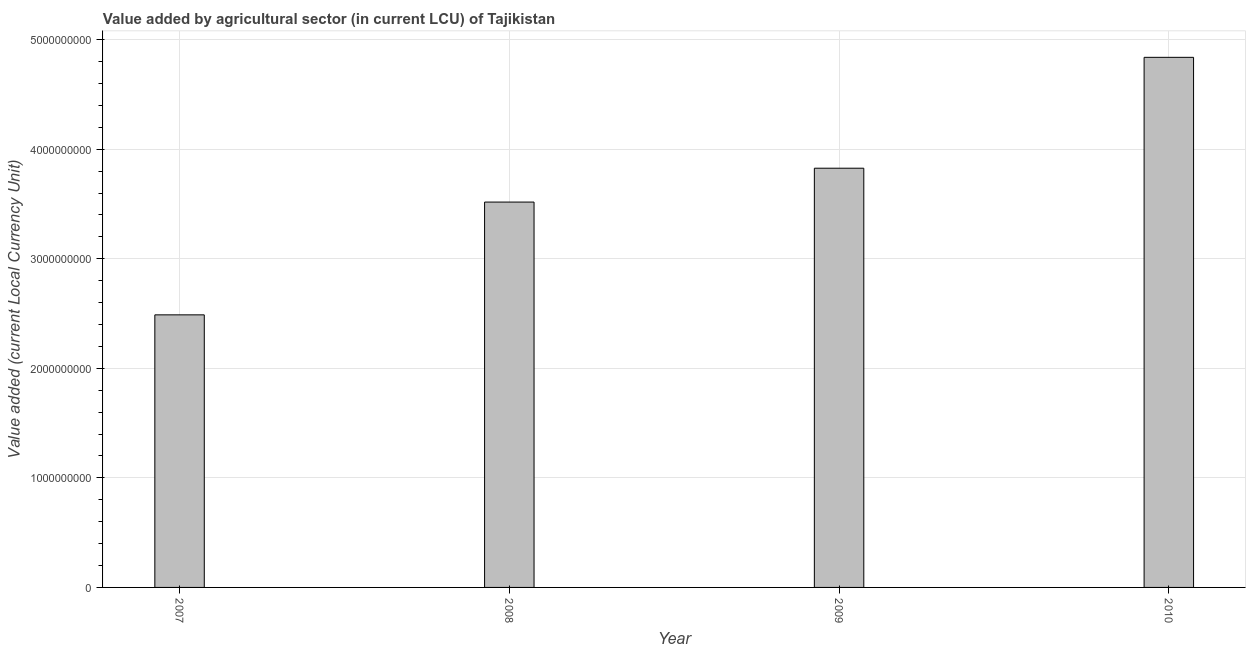Does the graph contain any zero values?
Offer a terse response. No. Does the graph contain grids?
Your answer should be compact. Yes. What is the title of the graph?
Provide a succinct answer. Value added by agricultural sector (in current LCU) of Tajikistan. What is the label or title of the Y-axis?
Offer a terse response. Value added (current Local Currency Unit). What is the value added by agriculture sector in 2009?
Keep it short and to the point. 3.83e+09. Across all years, what is the maximum value added by agriculture sector?
Your answer should be very brief. 4.84e+09. Across all years, what is the minimum value added by agriculture sector?
Make the answer very short. 2.49e+09. In which year was the value added by agriculture sector minimum?
Make the answer very short. 2007. What is the sum of the value added by agriculture sector?
Ensure brevity in your answer.  1.47e+1. What is the difference between the value added by agriculture sector in 2007 and 2010?
Provide a succinct answer. -2.35e+09. What is the average value added by agriculture sector per year?
Provide a short and direct response. 3.67e+09. What is the median value added by agriculture sector?
Provide a succinct answer. 3.67e+09. Do a majority of the years between 2008 and 2009 (inclusive) have value added by agriculture sector greater than 4000000000 LCU?
Provide a short and direct response. No. What is the ratio of the value added by agriculture sector in 2008 to that in 2009?
Provide a short and direct response. 0.92. What is the difference between the highest and the second highest value added by agriculture sector?
Your answer should be very brief. 1.01e+09. Is the sum of the value added by agriculture sector in 2007 and 2009 greater than the maximum value added by agriculture sector across all years?
Offer a terse response. Yes. What is the difference between the highest and the lowest value added by agriculture sector?
Offer a very short reply. 2.35e+09. In how many years, is the value added by agriculture sector greater than the average value added by agriculture sector taken over all years?
Offer a terse response. 2. How many bars are there?
Your answer should be compact. 4. Are all the bars in the graph horizontal?
Provide a short and direct response. No. How many years are there in the graph?
Provide a short and direct response. 4. Are the values on the major ticks of Y-axis written in scientific E-notation?
Provide a short and direct response. No. What is the Value added (current Local Currency Unit) in 2007?
Make the answer very short. 2.49e+09. What is the Value added (current Local Currency Unit) in 2008?
Make the answer very short. 3.52e+09. What is the Value added (current Local Currency Unit) in 2009?
Offer a very short reply. 3.83e+09. What is the Value added (current Local Currency Unit) in 2010?
Ensure brevity in your answer.  4.84e+09. What is the difference between the Value added (current Local Currency Unit) in 2007 and 2008?
Keep it short and to the point. -1.03e+09. What is the difference between the Value added (current Local Currency Unit) in 2007 and 2009?
Keep it short and to the point. -1.34e+09. What is the difference between the Value added (current Local Currency Unit) in 2007 and 2010?
Keep it short and to the point. -2.35e+09. What is the difference between the Value added (current Local Currency Unit) in 2008 and 2009?
Make the answer very short. -3.09e+08. What is the difference between the Value added (current Local Currency Unit) in 2008 and 2010?
Your response must be concise. -1.32e+09. What is the difference between the Value added (current Local Currency Unit) in 2009 and 2010?
Offer a terse response. -1.01e+09. What is the ratio of the Value added (current Local Currency Unit) in 2007 to that in 2008?
Give a very brief answer. 0.71. What is the ratio of the Value added (current Local Currency Unit) in 2007 to that in 2009?
Make the answer very short. 0.65. What is the ratio of the Value added (current Local Currency Unit) in 2007 to that in 2010?
Make the answer very short. 0.51. What is the ratio of the Value added (current Local Currency Unit) in 2008 to that in 2009?
Ensure brevity in your answer.  0.92. What is the ratio of the Value added (current Local Currency Unit) in 2008 to that in 2010?
Provide a short and direct response. 0.73. What is the ratio of the Value added (current Local Currency Unit) in 2009 to that in 2010?
Give a very brief answer. 0.79. 